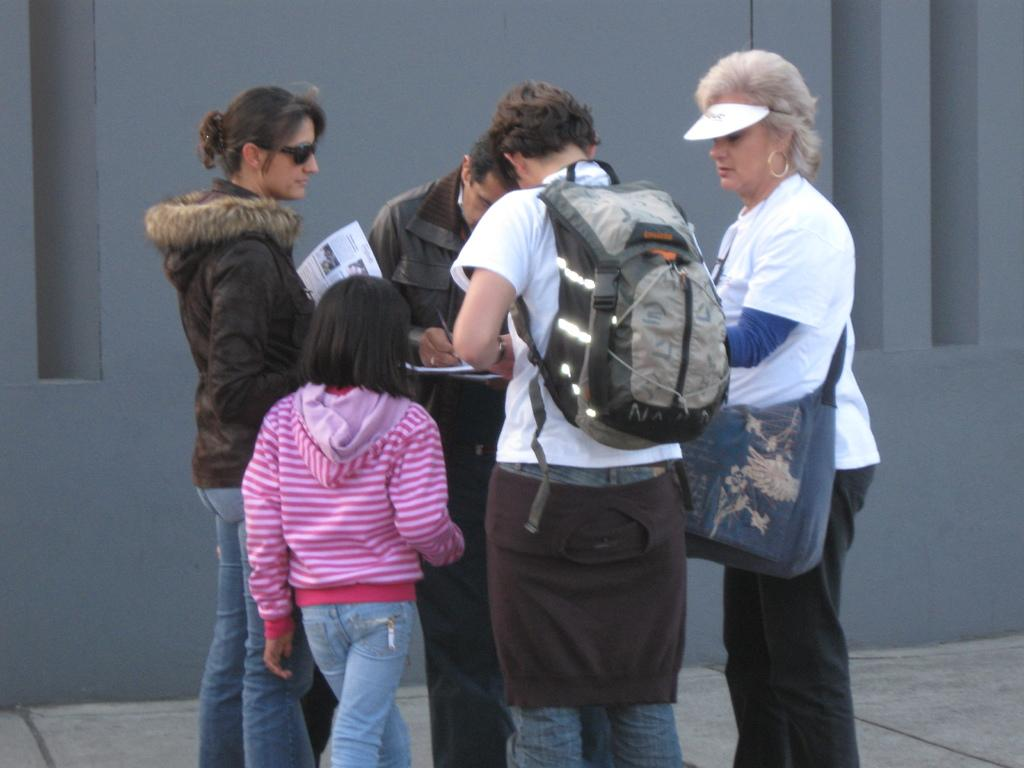What can be observed about the people in the image? There are people standing in the image, including a man in the center wearing a backpack, a lady next to him, and a girl beside him. What is the man in the center holding? The man in the center is wearing a backpack, but there is no mention of him holding anything else. What is visible in the background of the image? There is a wall in the background of the image. What type of oil is being used for the treatment in the image? There is no mention of oil or treatment in the image; it features people standing with a man wearing a backpack. 